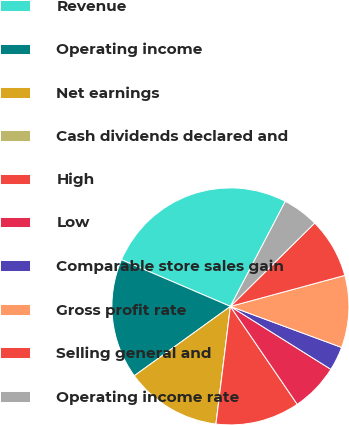Convert chart to OTSL. <chart><loc_0><loc_0><loc_500><loc_500><pie_chart><fcel>Revenue<fcel>Operating income<fcel>Net earnings<fcel>Cash dividends declared and<fcel>High<fcel>Low<fcel>Comparable store sales gain<fcel>Gross profit rate<fcel>Selling general and<fcel>Operating income rate<nl><fcel>26.23%<fcel>16.39%<fcel>13.11%<fcel>0.0%<fcel>11.48%<fcel>6.56%<fcel>3.28%<fcel>9.84%<fcel>8.2%<fcel>4.92%<nl></chart> 